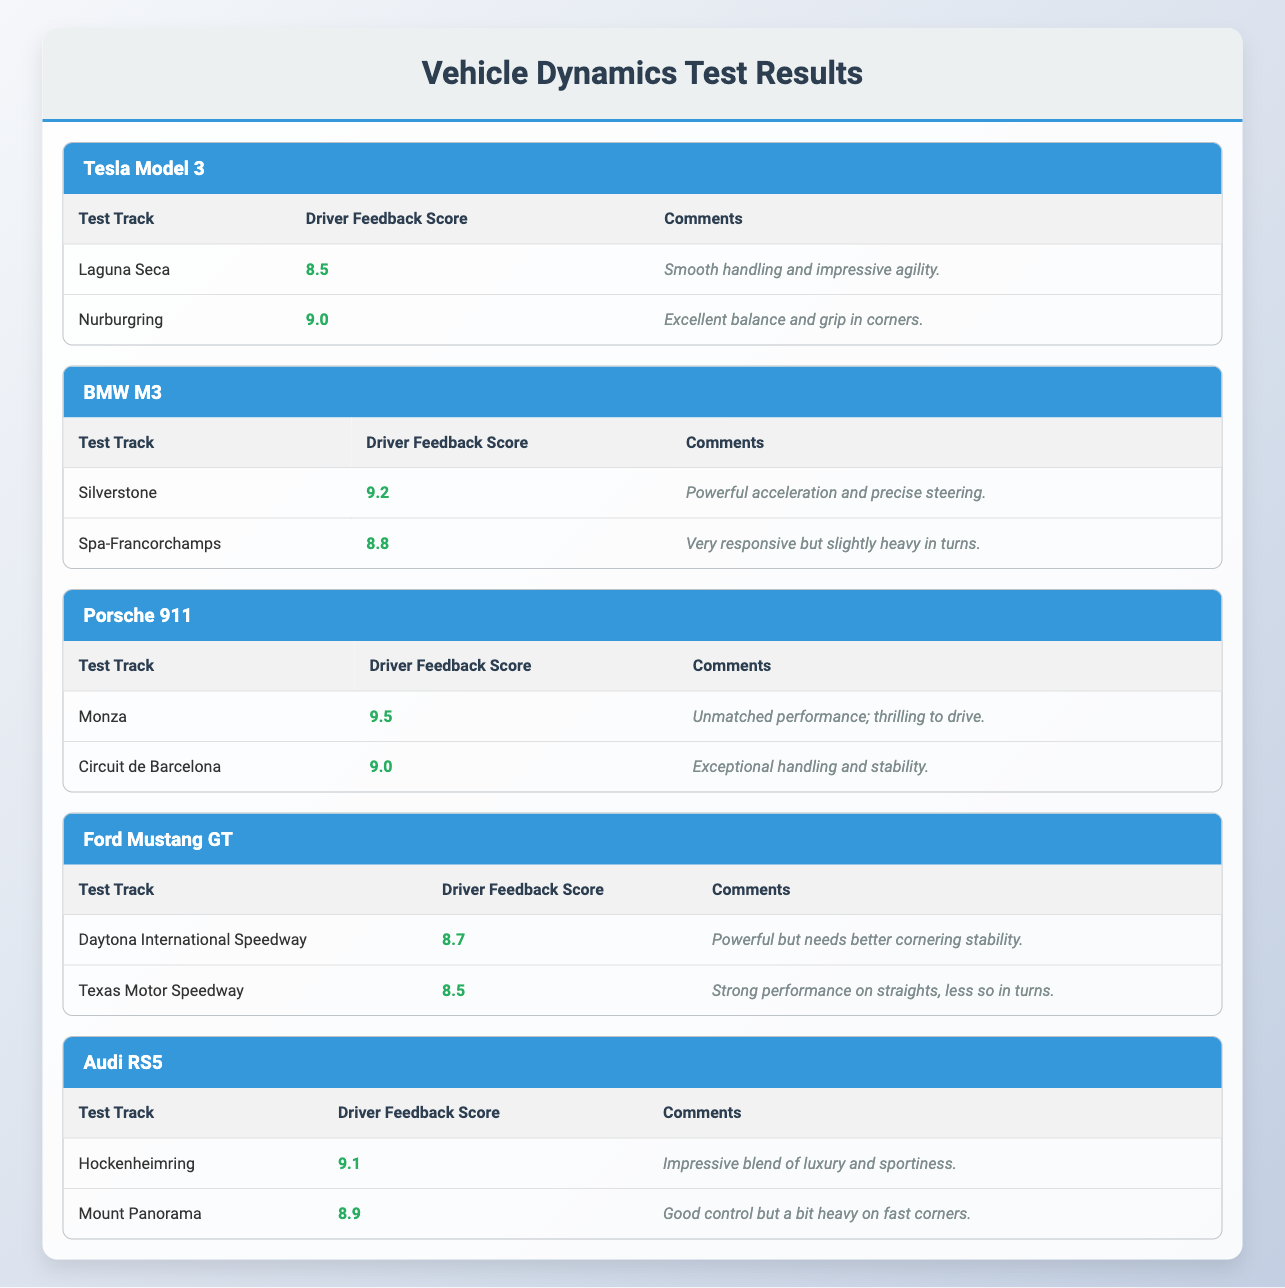What is the driver feedback score for the Tesla Model 3 at Laguna Seca? The table indicates that the Tesla Model 3 received a score of 8.5 at Laguna Seca. This can be found by locating the "Tesla Model 3" section and then looking for the corresponding score under the "Laguna Seca" entry.
Answer: 8.5 Which car model has the highest driver feedback score overall? The highest score is 9.5 given to the Porsche 911 at Monza. This is determined by reviewing all the scores listed for each car model and identifying the maximum value.
Answer: Porsche 911 Did the Ford Mustang GT score above 8.5 on both test tracks? No, the Ford Mustang GT scored 8.5 at Texas Motor Speedway, which is equal to the threshold, but only scored 8.7 at Daytona International Speedway, indicating it did not score above 8.5 on both tracks.
Answer: No What was the average driver feedback score for the Audi RS5? The total score for the Audi RS5 is 9.1 + 8.9 = 18.0 from the two tracks. To find the average, divide this total by 2, resulting in 18.0 / 2 = 9.0.
Answer: 9.0 Is there a car model that achieved a score of exactly 9.0? Yes, the Tesla Model 3 and the Porsche 911 both have scores of 9.0, specifically at Nurburgring and Circuit de Barcelona, respectively. This can be verified by scanning through the score values for each model.
Answer: Yes Which car scored the highest feedback at Silverstone, and what was the score? The BMW M3 achieved the highest feedback score of 9.2 at Silverstone, found in the BMW M3 section under the Silverstone entry.
Answer: 9.2 What is the difference between the highest score and the lowest score among all test tracks? The highest score is 9.5 (Porsche 911 at Monza), and the lowest score is 8.5 (Tesla Model 3 at Laguna Seca and Ford Mustang GT at Texas Motor Speedway). The difference is 9.5 - 8.5 = 1.0.
Answer: 1.0 Which track received the highest score across all models? Monza received the highest score of 9.5 from the Porsche 911, making it the highest-scoring test track. This is identified by reviewing the highest score listed in the table for each test track.
Answer: Monza What feedback was provided for the Porsche 911 at Circuit de Barcelona? The feedback for the Porsche 911 at Circuit de Barcelona is “Exceptional handling and stability,” which can be found under the corresponding entry in the Porsche 911 section.
Answer: Exceptional handling and stability 